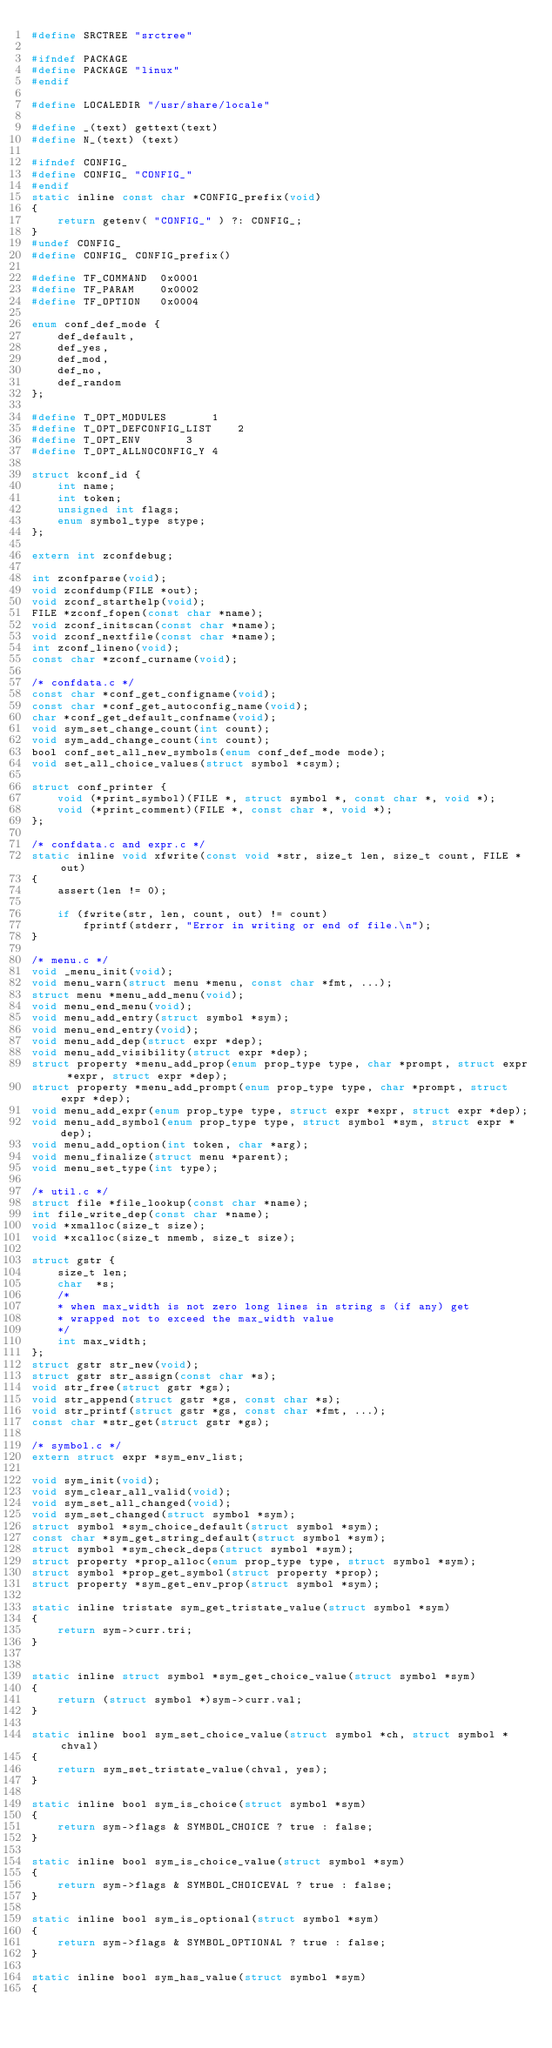Convert code to text. <code><loc_0><loc_0><loc_500><loc_500><_C_>#define SRCTREE "srctree"

#ifndef PACKAGE
#define PACKAGE "linux"
#endif

#define LOCALEDIR "/usr/share/locale"

#define _(text) gettext(text)
#define N_(text) (text)

#ifndef CONFIG_
#define CONFIG_ "CONFIG_"
#endif
static inline const char *CONFIG_prefix(void)
{
	return getenv( "CONFIG_" ) ?: CONFIG_;
}
#undef CONFIG_
#define CONFIG_ CONFIG_prefix()

#define TF_COMMAND	0x0001
#define TF_PARAM	0x0002
#define TF_OPTION	0x0004

enum conf_def_mode {
	def_default,
	def_yes,
	def_mod,
	def_no,
	def_random
};

#define T_OPT_MODULES		1
#define T_OPT_DEFCONFIG_LIST	2
#define T_OPT_ENV		3
#define T_OPT_ALLNOCONFIG_Y	4

struct kconf_id {
	int name;
	int token;
	unsigned int flags;
	enum symbol_type stype;
};

extern int zconfdebug;

int zconfparse(void);
void zconfdump(FILE *out);
void zconf_starthelp(void);
FILE *zconf_fopen(const char *name);
void zconf_initscan(const char *name);
void zconf_nextfile(const char *name);
int zconf_lineno(void);
const char *zconf_curname(void);

/* confdata.c */
const char *conf_get_configname(void);
const char *conf_get_autoconfig_name(void);
char *conf_get_default_confname(void);
void sym_set_change_count(int count);
void sym_add_change_count(int count);
bool conf_set_all_new_symbols(enum conf_def_mode mode);
void set_all_choice_values(struct symbol *csym);

struct conf_printer {
	void (*print_symbol)(FILE *, struct symbol *, const char *, void *);
	void (*print_comment)(FILE *, const char *, void *);
};

/* confdata.c and expr.c */
static inline void xfwrite(const void *str, size_t len, size_t count, FILE *out)
{
	assert(len != 0);

	if (fwrite(str, len, count, out) != count)
		fprintf(stderr, "Error in writing or end of file.\n");
}

/* menu.c */
void _menu_init(void);
void menu_warn(struct menu *menu, const char *fmt, ...);
struct menu *menu_add_menu(void);
void menu_end_menu(void);
void menu_add_entry(struct symbol *sym);
void menu_end_entry(void);
void menu_add_dep(struct expr *dep);
void menu_add_visibility(struct expr *dep);
struct property *menu_add_prop(enum prop_type type, char *prompt, struct expr *expr, struct expr *dep);
struct property *menu_add_prompt(enum prop_type type, char *prompt, struct expr *dep);
void menu_add_expr(enum prop_type type, struct expr *expr, struct expr *dep);
void menu_add_symbol(enum prop_type type, struct symbol *sym, struct expr *dep);
void menu_add_option(int token, char *arg);
void menu_finalize(struct menu *parent);
void menu_set_type(int type);

/* util.c */
struct file *file_lookup(const char *name);
int file_write_dep(const char *name);
void *xmalloc(size_t size);
void *xcalloc(size_t nmemb, size_t size);

struct gstr {
	size_t len;
	char  *s;
	/*
	* when max_width is not zero long lines in string s (if any) get
	* wrapped not to exceed the max_width value
	*/
	int max_width;
};
struct gstr str_new(void);
struct gstr str_assign(const char *s);
void str_free(struct gstr *gs);
void str_append(struct gstr *gs, const char *s);
void str_printf(struct gstr *gs, const char *fmt, ...);
const char *str_get(struct gstr *gs);

/* symbol.c */
extern struct expr *sym_env_list;

void sym_init(void);
void sym_clear_all_valid(void);
void sym_set_all_changed(void);
void sym_set_changed(struct symbol *sym);
struct symbol *sym_choice_default(struct symbol *sym);
const char *sym_get_string_default(struct symbol *sym);
struct symbol *sym_check_deps(struct symbol *sym);
struct property *prop_alloc(enum prop_type type, struct symbol *sym);
struct symbol *prop_get_symbol(struct property *prop);
struct property *sym_get_env_prop(struct symbol *sym);

static inline tristate sym_get_tristate_value(struct symbol *sym)
{
	return sym->curr.tri;
}


static inline struct symbol *sym_get_choice_value(struct symbol *sym)
{
	return (struct symbol *)sym->curr.val;
}

static inline bool sym_set_choice_value(struct symbol *ch, struct symbol *chval)
{
	return sym_set_tristate_value(chval, yes);
}

static inline bool sym_is_choice(struct symbol *sym)
{
	return sym->flags & SYMBOL_CHOICE ? true : false;
}

static inline bool sym_is_choice_value(struct symbol *sym)
{
	return sym->flags & SYMBOL_CHOICEVAL ? true : false;
}

static inline bool sym_is_optional(struct symbol *sym)
{
	return sym->flags & SYMBOL_OPTIONAL ? true : false;
}

static inline bool sym_has_value(struct symbol *sym)
{</code> 